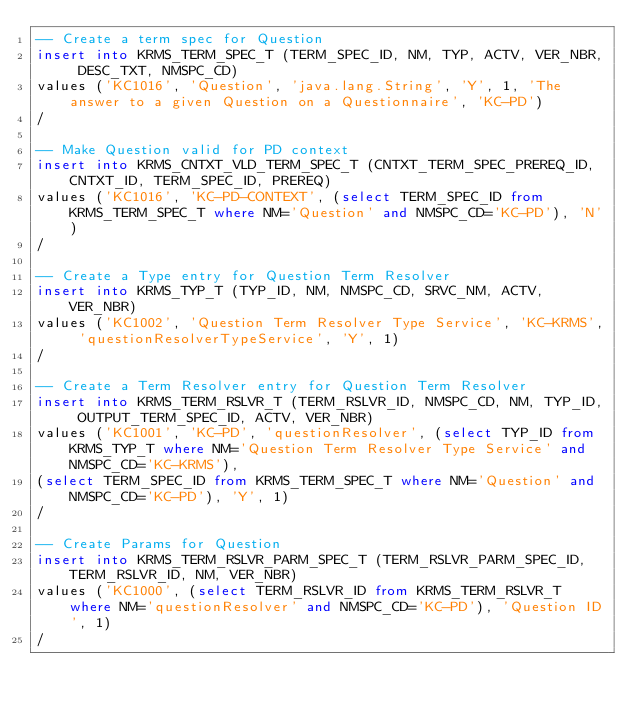<code> <loc_0><loc_0><loc_500><loc_500><_SQL_>-- Create a term spec for Question
insert into KRMS_TERM_SPEC_T (TERM_SPEC_ID, NM, TYP, ACTV, VER_NBR, DESC_TXT, NMSPC_CD) 
values ('KC1016', 'Question', 'java.lang.String', 'Y', 1, 'The answer to a given Question on a Questionnaire', 'KC-PD')
/

-- Make Question valid for PD context
insert into KRMS_CNTXT_VLD_TERM_SPEC_T (CNTXT_TERM_SPEC_PREREQ_ID, CNTXT_ID, TERM_SPEC_ID, PREREQ) 
values ('KC1016', 'KC-PD-CONTEXT', (select TERM_SPEC_ID from KRMS_TERM_SPEC_T where NM='Question' and NMSPC_CD='KC-PD'), 'N')
/

-- Create a Type entry for Question Term Resolver
insert into KRMS_TYP_T (TYP_ID, NM, NMSPC_CD, SRVC_NM, ACTV, VER_NBR) 
values ('KC1002', 'Question Term Resolver Type Service', 'KC-KRMS', 'questionResolverTypeService', 'Y', 1)
/

-- Create a Term Resolver entry for Question Term Resolver
insert into KRMS_TERM_RSLVR_T (TERM_RSLVR_ID, NMSPC_CD, NM, TYP_ID, OUTPUT_TERM_SPEC_ID, ACTV, VER_NBR) 
values ('KC1001', 'KC-PD', 'questionResolver', (select TYP_ID from KRMS_TYP_T where NM='Question Term Resolver Type Service' and NMSPC_CD='KC-KRMS'), 
(select TERM_SPEC_ID from KRMS_TERM_SPEC_T where NM='Question' and NMSPC_CD='KC-PD'), 'Y', 1)
/

-- Create Params for Question
insert into KRMS_TERM_RSLVR_PARM_SPEC_T (TERM_RSLVR_PARM_SPEC_ID, TERM_RSLVR_ID, NM, VER_NBR) 
values ('KC1000', (select TERM_RSLVR_ID from KRMS_TERM_RSLVR_T where NM='questionResolver' and NMSPC_CD='KC-PD'), 'Question ID', 1)
/
</code> 